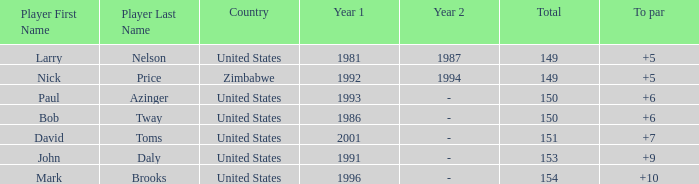How many to pars were won in 1993? 1.0. Give me the full table as a dictionary. {'header': ['Player First Name', 'Player Last Name', 'Country', 'Year 1', 'Year 2', 'Total', 'To par'], 'rows': [['Larry', 'Nelson', 'United States', '1981', '1987', '149', '+5'], ['Nick', 'Price', 'Zimbabwe', '1992', '1994', '149', '+5'], ['Paul', 'Azinger', 'United States', '1993', '-', '150', '+6'], ['Bob', 'Tway', 'United States', '1986', '-', '150', '+6'], ['David', 'Toms', 'United States', '2001', '-', '151', '+7'], ['John', 'Daly', 'United States', '1991', '-', '153', '+9'], ['Mark', 'Brooks', 'United States', '1996', '-', '154', '+10']]} 